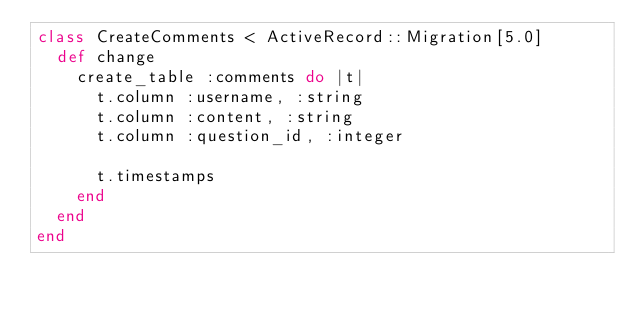Convert code to text. <code><loc_0><loc_0><loc_500><loc_500><_Ruby_>class CreateComments < ActiveRecord::Migration[5.0]
  def change
    create_table :comments do |t|
      t.column :username, :string
      t.column :content, :string
      t.column :question_id, :integer

      t.timestamps
    end
  end
end
</code> 